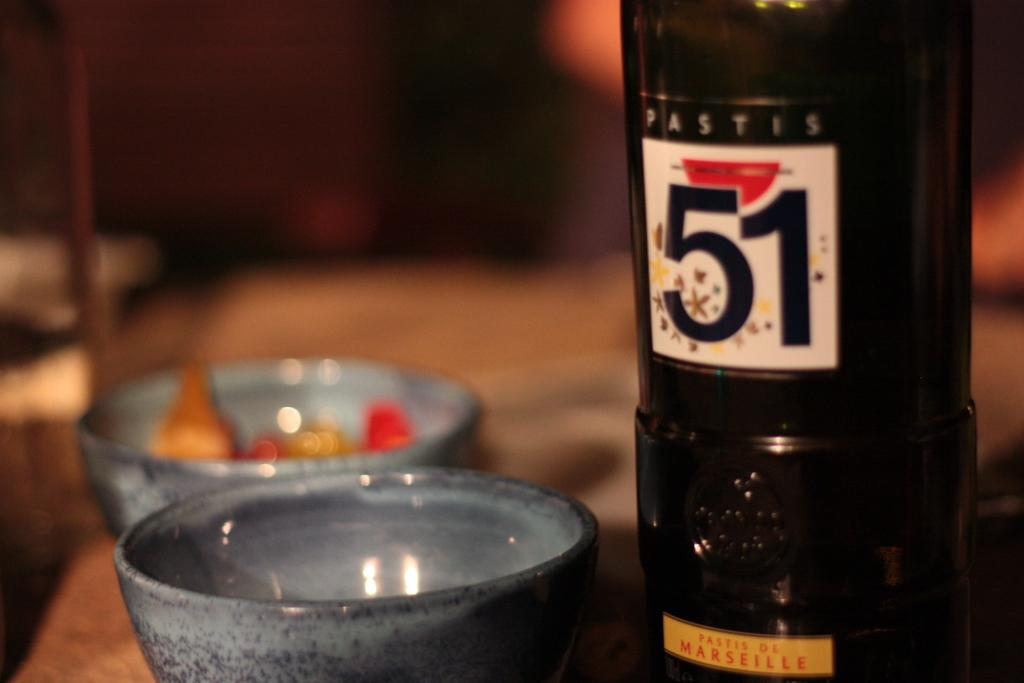<image>
Describe the image concisely. An elegant bottle of Pastis wine awaits the two grey cups. 